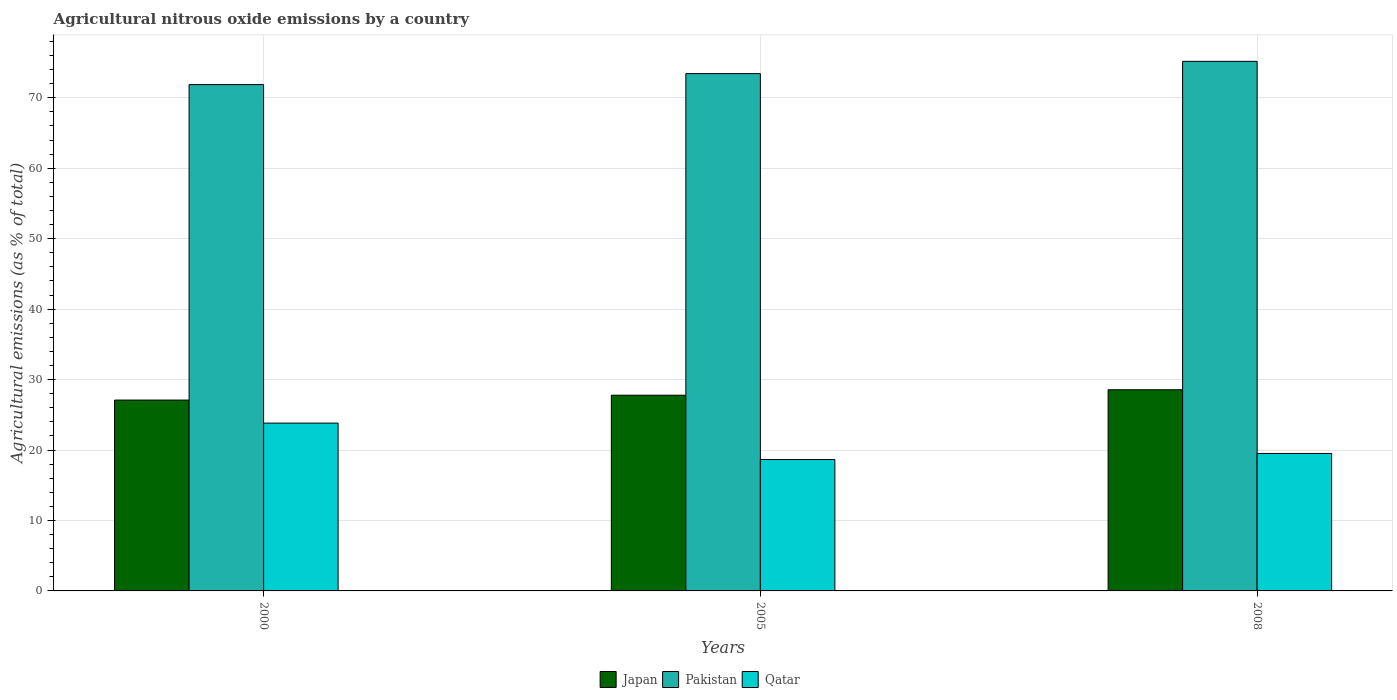How many different coloured bars are there?
Give a very brief answer. 3. How many groups of bars are there?
Provide a short and direct response. 3. Are the number of bars on each tick of the X-axis equal?
Your answer should be very brief. Yes. How many bars are there on the 2nd tick from the left?
Offer a very short reply. 3. What is the label of the 3rd group of bars from the left?
Ensure brevity in your answer.  2008. What is the amount of agricultural nitrous oxide emitted in Japan in 2008?
Your response must be concise. 28.55. Across all years, what is the maximum amount of agricultural nitrous oxide emitted in Qatar?
Make the answer very short. 23.82. Across all years, what is the minimum amount of agricultural nitrous oxide emitted in Qatar?
Offer a very short reply. 18.65. What is the total amount of agricultural nitrous oxide emitted in Pakistan in the graph?
Ensure brevity in your answer.  220.46. What is the difference between the amount of agricultural nitrous oxide emitted in Pakistan in 2000 and that in 2008?
Provide a short and direct response. -3.3. What is the difference between the amount of agricultural nitrous oxide emitted in Japan in 2008 and the amount of agricultural nitrous oxide emitted in Pakistan in 2000?
Offer a very short reply. -43.31. What is the average amount of agricultural nitrous oxide emitted in Pakistan per year?
Keep it short and to the point. 73.49. In the year 2000, what is the difference between the amount of agricultural nitrous oxide emitted in Japan and amount of agricultural nitrous oxide emitted in Pakistan?
Your answer should be very brief. -44.78. What is the ratio of the amount of agricultural nitrous oxide emitted in Qatar in 2000 to that in 2005?
Keep it short and to the point. 1.28. Is the amount of agricultural nitrous oxide emitted in Pakistan in 2000 less than that in 2008?
Keep it short and to the point. Yes. Is the difference between the amount of agricultural nitrous oxide emitted in Japan in 2000 and 2008 greater than the difference between the amount of agricultural nitrous oxide emitted in Pakistan in 2000 and 2008?
Your answer should be very brief. Yes. What is the difference between the highest and the second highest amount of agricultural nitrous oxide emitted in Qatar?
Ensure brevity in your answer.  4.31. What is the difference between the highest and the lowest amount of agricultural nitrous oxide emitted in Japan?
Your answer should be compact. 1.46. In how many years, is the amount of agricultural nitrous oxide emitted in Qatar greater than the average amount of agricultural nitrous oxide emitted in Qatar taken over all years?
Offer a very short reply. 1. What does the 1st bar from the right in 2000 represents?
Make the answer very short. Qatar. Is it the case that in every year, the sum of the amount of agricultural nitrous oxide emitted in Pakistan and amount of agricultural nitrous oxide emitted in Japan is greater than the amount of agricultural nitrous oxide emitted in Qatar?
Ensure brevity in your answer.  Yes. How many bars are there?
Make the answer very short. 9. Are all the bars in the graph horizontal?
Provide a short and direct response. No. How many years are there in the graph?
Offer a very short reply. 3. Does the graph contain any zero values?
Provide a short and direct response. No. Does the graph contain grids?
Keep it short and to the point. Yes. How many legend labels are there?
Provide a succinct answer. 3. How are the legend labels stacked?
Make the answer very short. Horizontal. What is the title of the graph?
Offer a very short reply. Agricultural nitrous oxide emissions by a country. Does "Argentina" appear as one of the legend labels in the graph?
Offer a very short reply. No. What is the label or title of the X-axis?
Your response must be concise. Years. What is the label or title of the Y-axis?
Offer a terse response. Agricultural emissions (as % of total). What is the Agricultural emissions (as % of total) in Japan in 2000?
Your answer should be compact. 27.09. What is the Agricultural emissions (as % of total) in Pakistan in 2000?
Keep it short and to the point. 71.86. What is the Agricultural emissions (as % of total) of Qatar in 2000?
Make the answer very short. 23.82. What is the Agricultural emissions (as % of total) in Japan in 2005?
Give a very brief answer. 27.78. What is the Agricultural emissions (as % of total) in Pakistan in 2005?
Make the answer very short. 73.43. What is the Agricultural emissions (as % of total) of Qatar in 2005?
Your answer should be compact. 18.65. What is the Agricultural emissions (as % of total) of Japan in 2008?
Your response must be concise. 28.55. What is the Agricultural emissions (as % of total) of Pakistan in 2008?
Provide a short and direct response. 75.17. What is the Agricultural emissions (as % of total) of Qatar in 2008?
Provide a short and direct response. 19.51. Across all years, what is the maximum Agricultural emissions (as % of total) of Japan?
Offer a terse response. 28.55. Across all years, what is the maximum Agricultural emissions (as % of total) in Pakistan?
Provide a succinct answer. 75.17. Across all years, what is the maximum Agricultural emissions (as % of total) of Qatar?
Keep it short and to the point. 23.82. Across all years, what is the minimum Agricultural emissions (as % of total) of Japan?
Offer a terse response. 27.09. Across all years, what is the minimum Agricultural emissions (as % of total) of Pakistan?
Your answer should be very brief. 71.86. Across all years, what is the minimum Agricultural emissions (as % of total) of Qatar?
Your answer should be compact. 18.65. What is the total Agricultural emissions (as % of total) of Japan in the graph?
Make the answer very short. 83.42. What is the total Agricultural emissions (as % of total) of Pakistan in the graph?
Ensure brevity in your answer.  220.46. What is the total Agricultural emissions (as % of total) of Qatar in the graph?
Offer a terse response. 61.98. What is the difference between the Agricultural emissions (as % of total) in Japan in 2000 and that in 2005?
Offer a very short reply. -0.69. What is the difference between the Agricultural emissions (as % of total) in Pakistan in 2000 and that in 2005?
Your answer should be compact. -1.56. What is the difference between the Agricultural emissions (as % of total) of Qatar in 2000 and that in 2005?
Make the answer very short. 5.17. What is the difference between the Agricultural emissions (as % of total) in Japan in 2000 and that in 2008?
Provide a short and direct response. -1.46. What is the difference between the Agricultural emissions (as % of total) of Pakistan in 2000 and that in 2008?
Ensure brevity in your answer.  -3.3. What is the difference between the Agricultural emissions (as % of total) of Qatar in 2000 and that in 2008?
Ensure brevity in your answer.  4.31. What is the difference between the Agricultural emissions (as % of total) of Japan in 2005 and that in 2008?
Make the answer very short. -0.77. What is the difference between the Agricultural emissions (as % of total) of Pakistan in 2005 and that in 2008?
Provide a succinct answer. -1.74. What is the difference between the Agricultural emissions (as % of total) of Qatar in 2005 and that in 2008?
Provide a succinct answer. -0.86. What is the difference between the Agricultural emissions (as % of total) in Japan in 2000 and the Agricultural emissions (as % of total) in Pakistan in 2005?
Keep it short and to the point. -46.34. What is the difference between the Agricultural emissions (as % of total) in Japan in 2000 and the Agricultural emissions (as % of total) in Qatar in 2005?
Keep it short and to the point. 8.44. What is the difference between the Agricultural emissions (as % of total) of Pakistan in 2000 and the Agricultural emissions (as % of total) of Qatar in 2005?
Make the answer very short. 53.22. What is the difference between the Agricultural emissions (as % of total) in Japan in 2000 and the Agricultural emissions (as % of total) in Pakistan in 2008?
Offer a very short reply. -48.08. What is the difference between the Agricultural emissions (as % of total) of Japan in 2000 and the Agricultural emissions (as % of total) of Qatar in 2008?
Make the answer very short. 7.58. What is the difference between the Agricultural emissions (as % of total) of Pakistan in 2000 and the Agricultural emissions (as % of total) of Qatar in 2008?
Your answer should be compact. 52.35. What is the difference between the Agricultural emissions (as % of total) of Japan in 2005 and the Agricultural emissions (as % of total) of Pakistan in 2008?
Your answer should be compact. -47.39. What is the difference between the Agricultural emissions (as % of total) in Japan in 2005 and the Agricultural emissions (as % of total) in Qatar in 2008?
Provide a short and direct response. 8.27. What is the difference between the Agricultural emissions (as % of total) of Pakistan in 2005 and the Agricultural emissions (as % of total) of Qatar in 2008?
Your answer should be very brief. 53.92. What is the average Agricultural emissions (as % of total) of Japan per year?
Offer a terse response. 27.81. What is the average Agricultural emissions (as % of total) of Pakistan per year?
Give a very brief answer. 73.49. What is the average Agricultural emissions (as % of total) of Qatar per year?
Your response must be concise. 20.66. In the year 2000, what is the difference between the Agricultural emissions (as % of total) in Japan and Agricultural emissions (as % of total) in Pakistan?
Give a very brief answer. -44.78. In the year 2000, what is the difference between the Agricultural emissions (as % of total) in Japan and Agricultural emissions (as % of total) in Qatar?
Your response must be concise. 3.27. In the year 2000, what is the difference between the Agricultural emissions (as % of total) of Pakistan and Agricultural emissions (as % of total) of Qatar?
Your response must be concise. 48.04. In the year 2005, what is the difference between the Agricultural emissions (as % of total) of Japan and Agricultural emissions (as % of total) of Pakistan?
Make the answer very short. -45.65. In the year 2005, what is the difference between the Agricultural emissions (as % of total) in Japan and Agricultural emissions (as % of total) in Qatar?
Provide a succinct answer. 9.13. In the year 2005, what is the difference between the Agricultural emissions (as % of total) in Pakistan and Agricultural emissions (as % of total) in Qatar?
Your answer should be very brief. 54.78. In the year 2008, what is the difference between the Agricultural emissions (as % of total) of Japan and Agricultural emissions (as % of total) of Pakistan?
Provide a short and direct response. -46.61. In the year 2008, what is the difference between the Agricultural emissions (as % of total) of Japan and Agricultural emissions (as % of total) of Qatar?
Offer a terse response. 9.04. In the year 2008, what is the difference between the Agricultural emissions (as % of total) of Pakistan and Agricultural emissions (as % of total) of Qatar?
Keep it short and to the point. 55.65. What is the ratio of the Agricultural emissions (as % of total) of Japan in 2000 to that in 2005?
Provide a short and direct response. 0.98. What is the ratio of the Agricultural emissions (as % of total) in Pakistan in 2000 to that in 2005?
Provide a short and direct response. 0.98. What is the ratio of the Agricultural emissions (as % of total) in Qatar in 2000 to that in 2005?
Ensure brevity in your answer.  1.28. What is the ratio of the Agricultural emissions (as % of total) in Japan in 2000 to that in 2008?
Provide a short and direct response. 0.95. What is the ratio of the Agricultural emissions (as % of total) in Pakistan in 2000 to that in 2008?
Make the answer very short. 0.96. What is the ratio of the Agricultural emissions (as % of total) in Qatar in 2000 to that in 2008?
Offer a terse response. 1.22. What is the ratio of the Agricultural emissions (as % of total) in Japan in 2005 to that in 2008?
Offer a very short reply. 0.97. What is the ratio of the Agricultural emissions (as % of total) of Pakistan in 2005 to that in 2008?
Your response must be concise. 0.98. What is the ratio of the Agricultural emissions (as % of total) in Qatar in 2005 to that in 2008?
Provide a short and direct response. 0.96. What is the difference between the highest and the second highest Agricultural emissions (as % of total) of Japan?
Provide a succinct answer. 0.77. What is the difference between the highest and the second highest Agricultural emissions (as % of total) of Pakistan?
Make the answer very short. 1.74. What is the difference between the highest and the second highest Agricultural emissions (as % of total) of Qatar?
Provide a succinct answer. 4.31. What is the difference between the highest and the lowest Agricultural emissions (as % of total) of Japan?
Keep it short and to the point. 1.46. What is the difference between the highest and the lowest Agricultural emissions (as % of total) of Pakistan?
Offer a very short reply. 3.3. What is the difference between the highest and the lowest Agricultural emissions (as % of total) in Qatar?
Offer a very short reply. 5.17. 